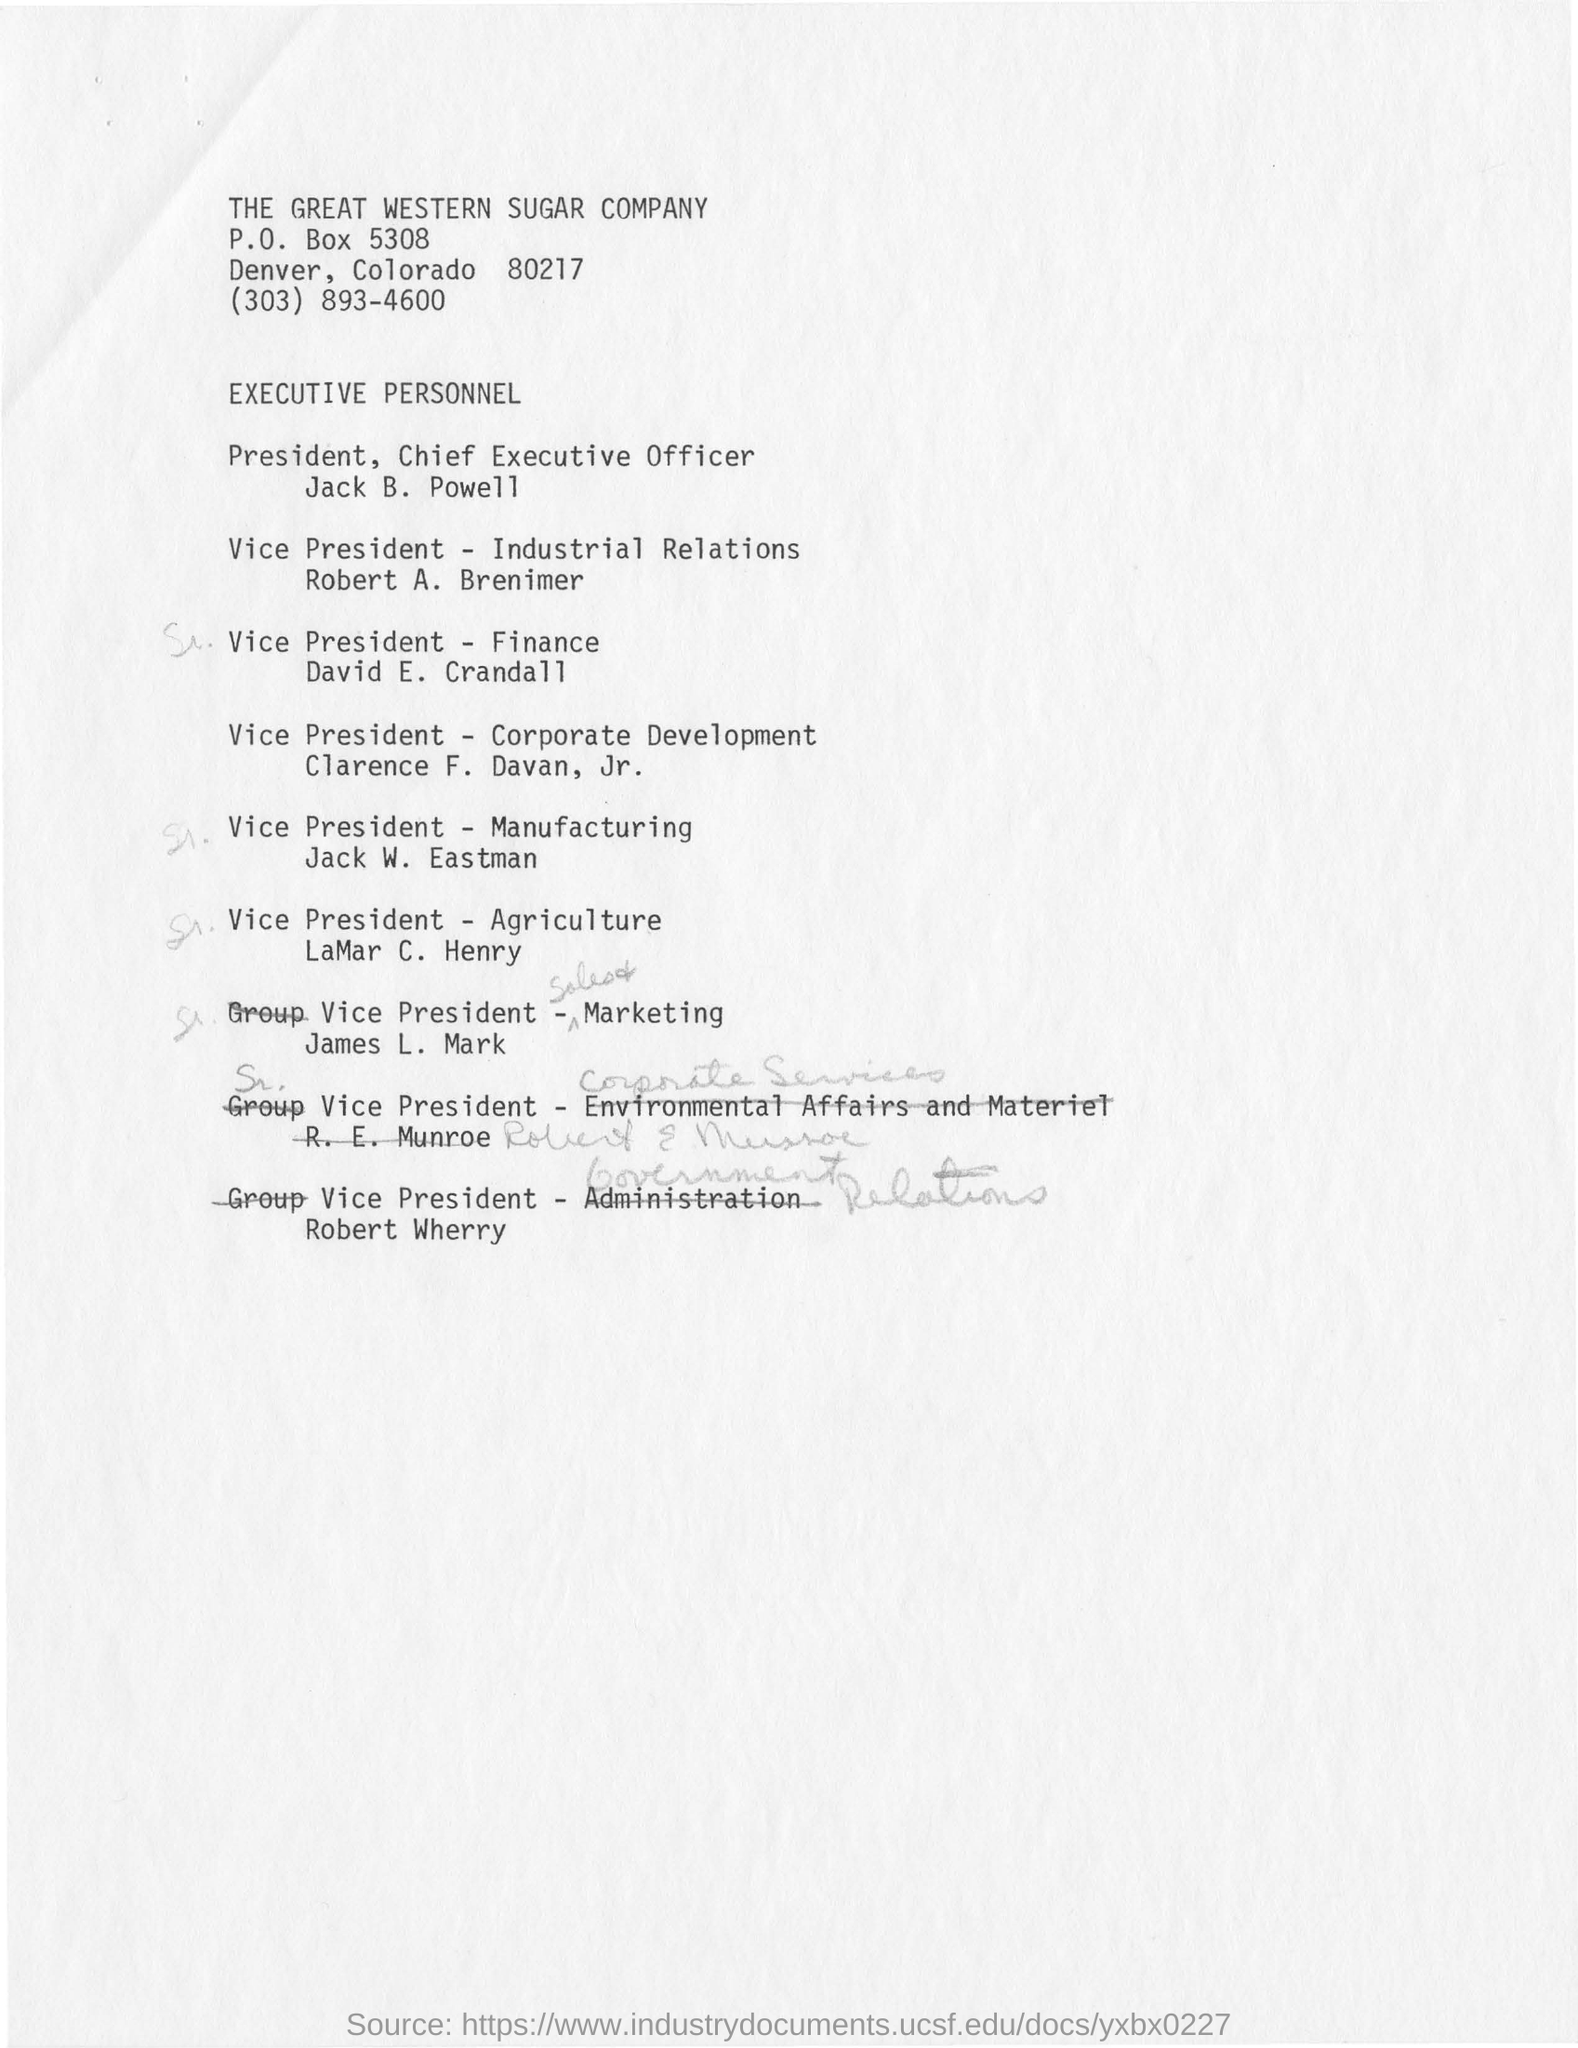Give some essential details in this illustration. David E. Crandall is the vice president of finance. Robert A. Brenimer is the Vice President of Industrial Relations. The Great Western Sugar Company is the name of a sugar company. 